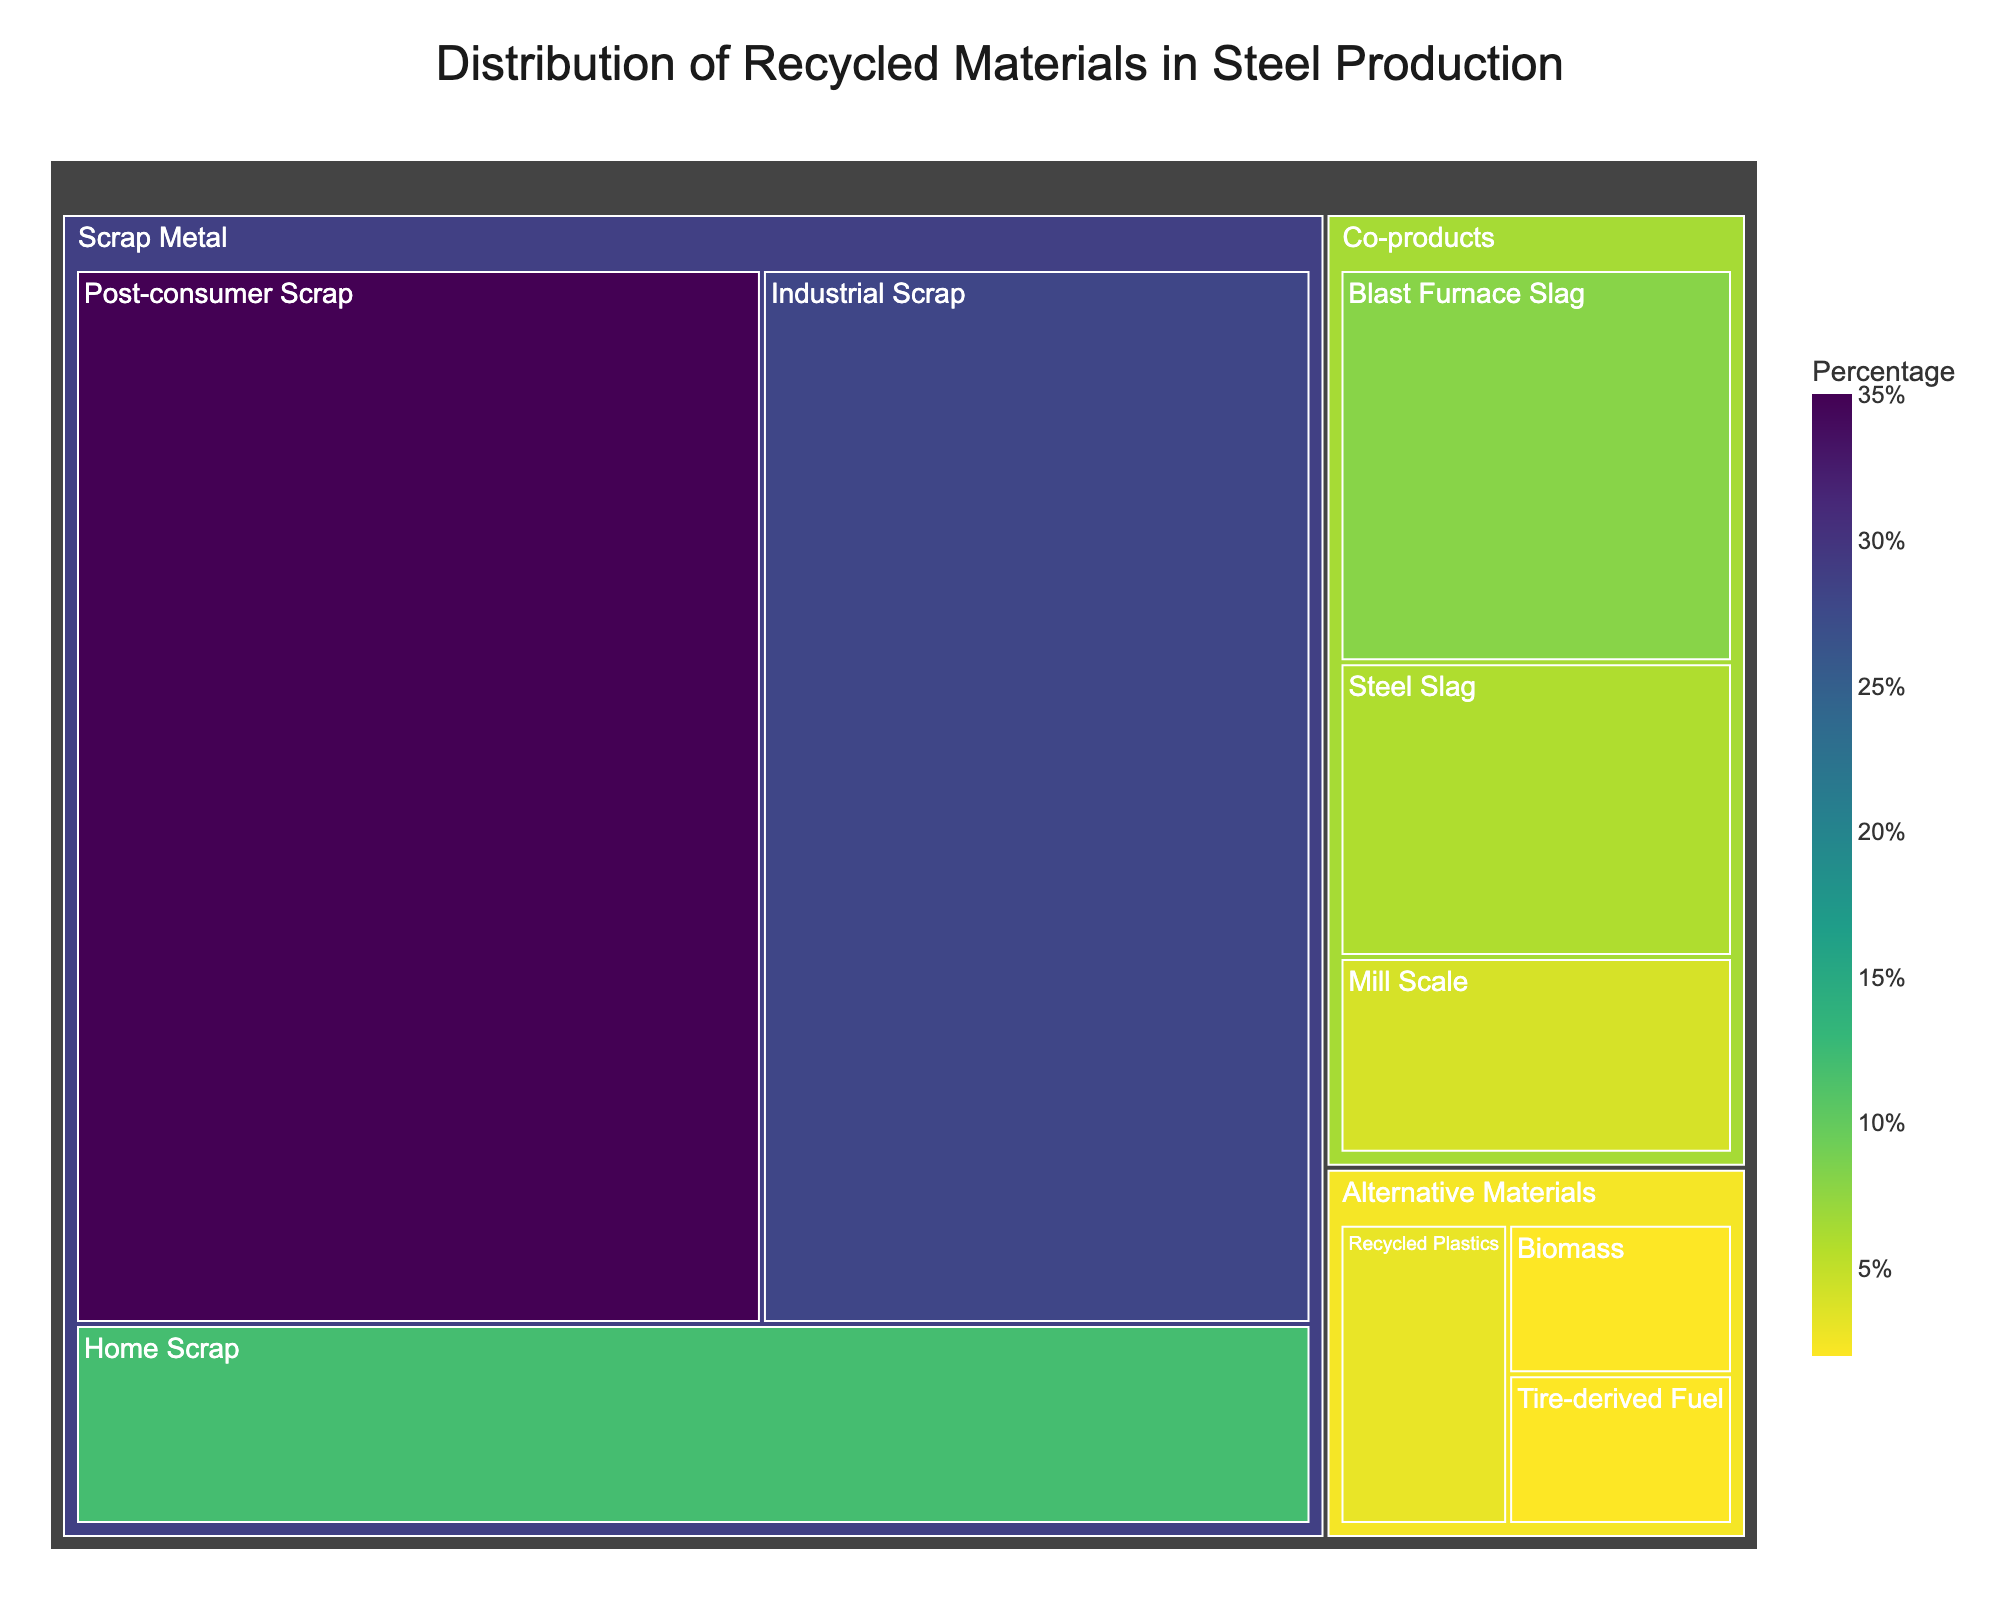What's the title of this treemap? The title of the treemap is displayed at the top of the visual. It provides an overview of what the chart represents, which in this case is the distribution of recycled materials in steel production.
Answer: Distribution of Recycled Materials in Steel Production Which subcategory has the highest value in the treemap? To determine the subcategory with the highest value, observe the largest segment within the treemap. The subcategory "Post-consumer Scrap" under "Scrap Metal" is the largest and hence has the highest value.
Answer: Post-consumer Scrap What is the combined value of all "Co-products" categories in the treemap? Sum the values of all subcategories under the "Co-products" category: Blast Furnace Slag (8) + Steel Slag (6) + Mill Scale (4). This adds up to 18.
Answer: 18 How does the value of "Recycled Plastics" compare to "Tire-derived Fuel"? Compare the values given for each subcategory: Recycled Plastics (3) and Tire-derived Fuel (2). Recycled Plastics has a higher value.
Answer: Recycled Plastics has a higher value What percentage of the total does "Industrial Scrap" contribute? First, sum all the values to get the total. Total = 35 + 28 + 12 + 8 + 6 + 4 + 3 + 2 + 2 = 100. The value for "Industrial Scrap" is 28, so the percentage is (28/100) * 100% = 28%.
Answer: 28% Which subcategory within "Alternative Materials" has the lowest value? Observe the smallest segment within the "Alternative Materials" category. Both "Tire-derived Fuel" and "Biomass" have the lowest values of 2.
Answer: Tire-derived Fuel and Biomass Is "Home Scrap" a larger or smaller contributor compared to "Steel Slag"? Compare the values for "Home Scrap" (12) and "Steel Slag" (6). "Home Scrap" is a larger contributor.
Answer: Larger By how much does "Post-consumer Scrap" exceed the value of "Industrial Scrap"? Subtract the value of "Industrial Scrap" from "Post-consumer Scrap": 35 - 28 = 7.
Answer: 7 What is the color scheme used in the treemap? The colors in the treemap range from dark to light tones based on the value, utilizing a sequential color scale called Viridis. This helps in distinguishing different subcategories based on their values.
Answer: Viridis How many subcategories are shown in the treemap? Count the distinct boxes or segments within the treemap. Each segment represents a subcategory. The treemap comprises 9 subcategories.
Answer: 9 